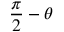<formula> <loc_0><loc_0><loc_500><loc_500>{ \frac { \pi } { 2 } } - \theta</formula> 